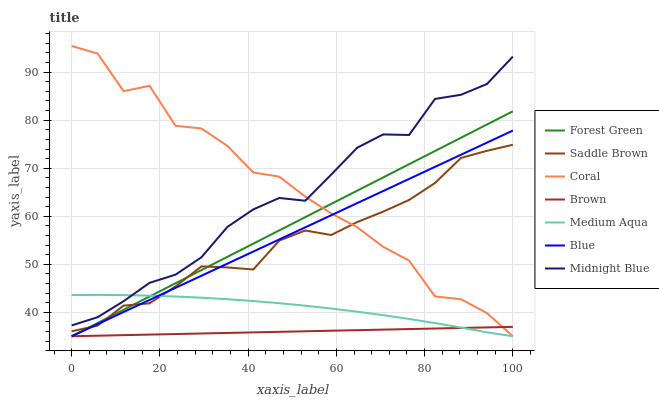Does Brown have the minimum area under the curve?
Answer yes or no. Yes. Does Coral have the maximum area under the curve?
Answer yes or no. Yes. Does Midnight Blue have the minimum area under the curve?
Answer yes or no. No. Does Midnight Blue have the maximum area under the curve?
Answer yes or no. No. Is Brown the smoothest?
Answer yes or no. Yes. Is Coral the roughest?
Answer yes or no. Yes. Is Midnight Blue the smoothest?
Answer yes or no. No. Is Midnight Blue the roughest?
Answer yes or no. No. Does Blue have the lowest value?
Answer yes or no. Yes. Does Midnight Blue have the lowest value?
Answer yes or no. No. Does Coral have the highest value?
Answer yes or no. Yes. Does Midnight Blue have the highest value?
Answer yes or no. No. Is Forest Green less than Midnight Blue?
Answer yes or no. Yes. Is Midnight Blue greater than Blue?
Answer yes or no. Yes. Does Medium Aqua intersect Blue?
Answer yes or no. Yes. Is Medium Aqua less than Blue?
Answer yes or no. No. Is Medium Aqua greater than Blue?
Answer yes or no. No. Does Forest Green intersect Midnight Blue?
Answer yes or no. No. 